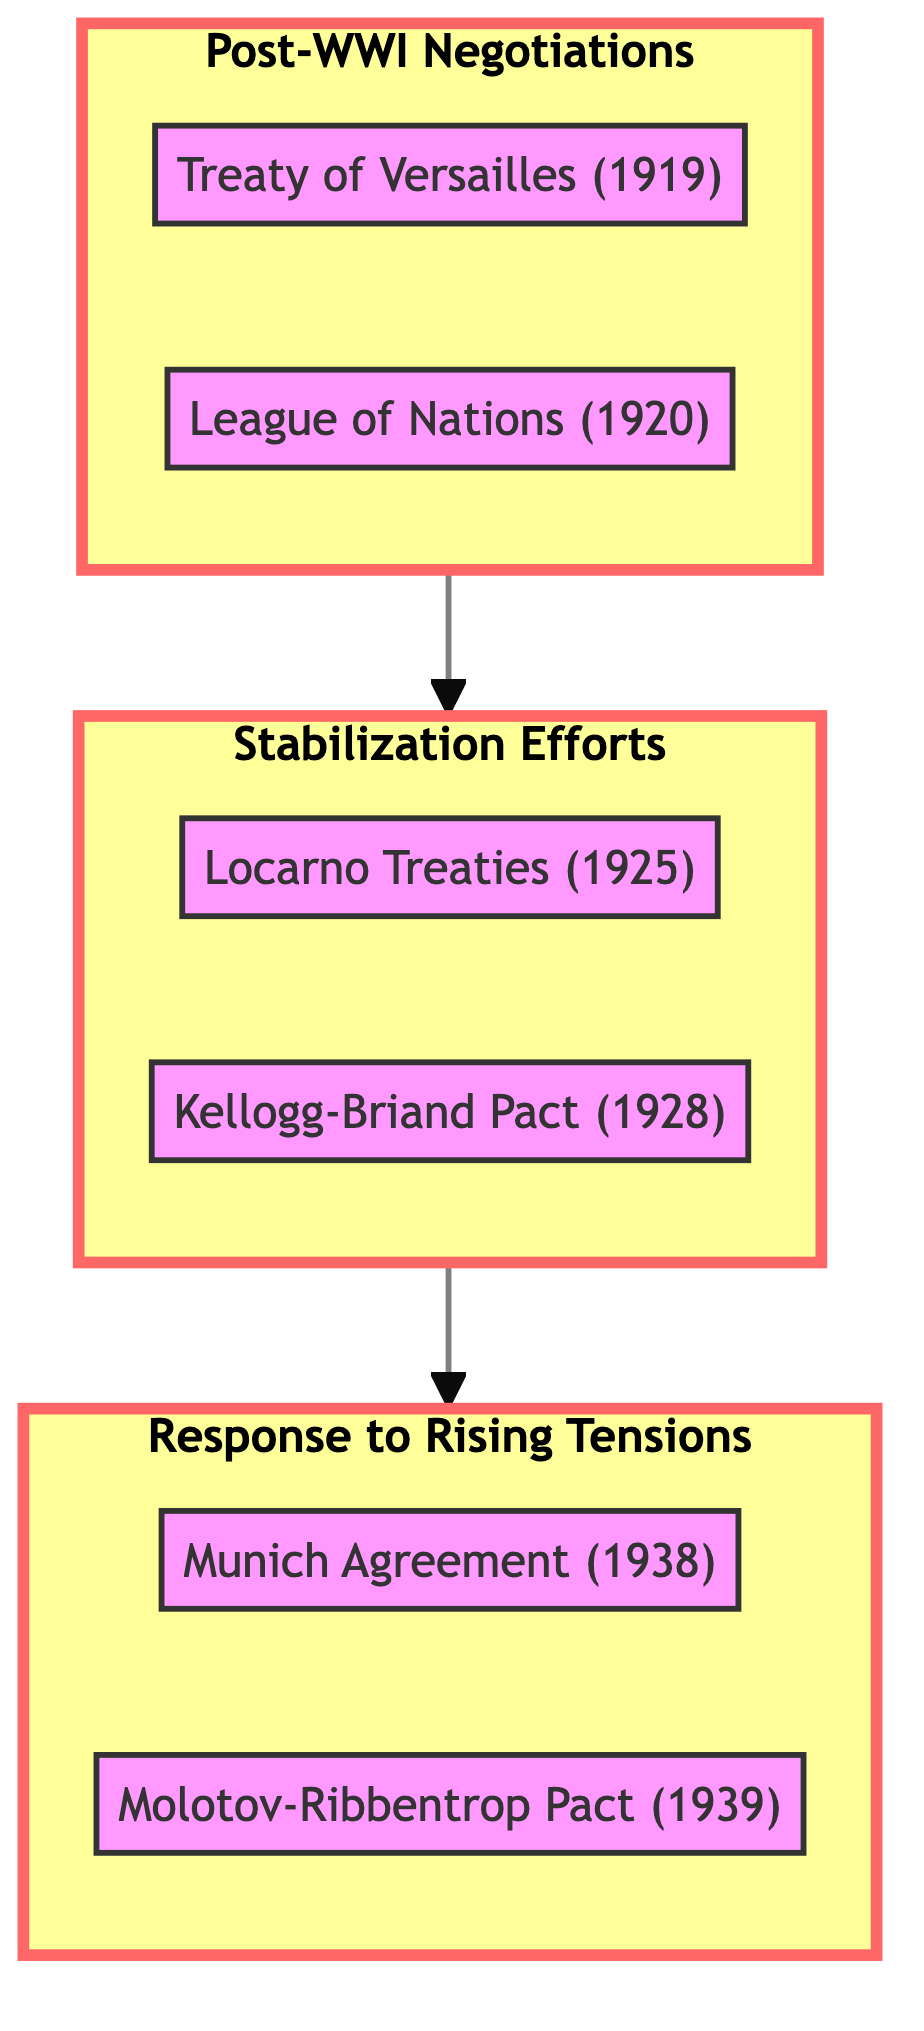What event marked the end of WWI? The "Treaty of Versailles" in 1919 ended WWI and is the first event listed under the "Post-WWI Negotiations" phase.
Answer: Treaty of Versailles What year was the League of Nations founded? The League of Nations was founded in 1920, as indicated in the diagram under the "Post-WWI Negotiations" phase.
Answer: 1920 How many main phases are represented in the diagram? The diagram clearly shows three main phases: "Post-WWI Negotiations," "Stabilization Efforts," and "Response to Rising Tensions."
Answer: 3 Which agreement aimed to renounce war? The "Kellogg-Briand Pact" of 1928 aimed to renounce war as a means of conflict resolution, as depicted in the "Stabilization Efforts" phase.
Answer: Kellogg-Briand Pact What was the significance of the Munich Agreement? The Munich Agreement permitted Nazi Germany's annexation of Czechoslovakia's Sudetenland in 1938, representing a critical point in the "Response to Rising Tensions" phase.
Answer: Permitted annexation What sequence of phases depicts the evolution from post-WWI negotiations to rising tensions? The sequence begins with "Post-WWI Negotiations" -> "Stabilization Efforts" -> "Response to Rising Tensions," showing a linear progression of events and responses.
Answer: Post-WWI Negotiations to Stabilization Efforts to Response to Rising Tensions What was the goal of the Locarno Treaties? The goal of the Locarno Treaties in 1925 was to secure post-war territorial settlements and normalize relations with Germany, as noted in the "Stabilization Efforts" phase.
Answer: Secure settlements Which two agreements indicated diplomatic relations between Germany and the Soviet Union? The "Molotov-Ribbentrop Pact" of 1939 indicates a non-aggression agreement between Nazi Germany and the Soviet Union, highlighted in the "Response to Rising Tensions."
Answer: Molotov-Ribbentrop Pact What is a significant implication of the the League of Nations? A significant implication was the attempt to promote international cooperation and peace, as expressed in the diagram for the year 1920 under "Post-WWI Negotiations."
Answer: Promote cooperation What specific event occurred in 1939 that indicated rising tensions prior to WWII? The "Molotov-Ribbentrop Pact" in 1939 represents a significant diplomatic move illustrating rising tensions, and it is the last event in the "Response to Rising Tensions" phase.
Answer: Molotov-Ribbentrop Pact 